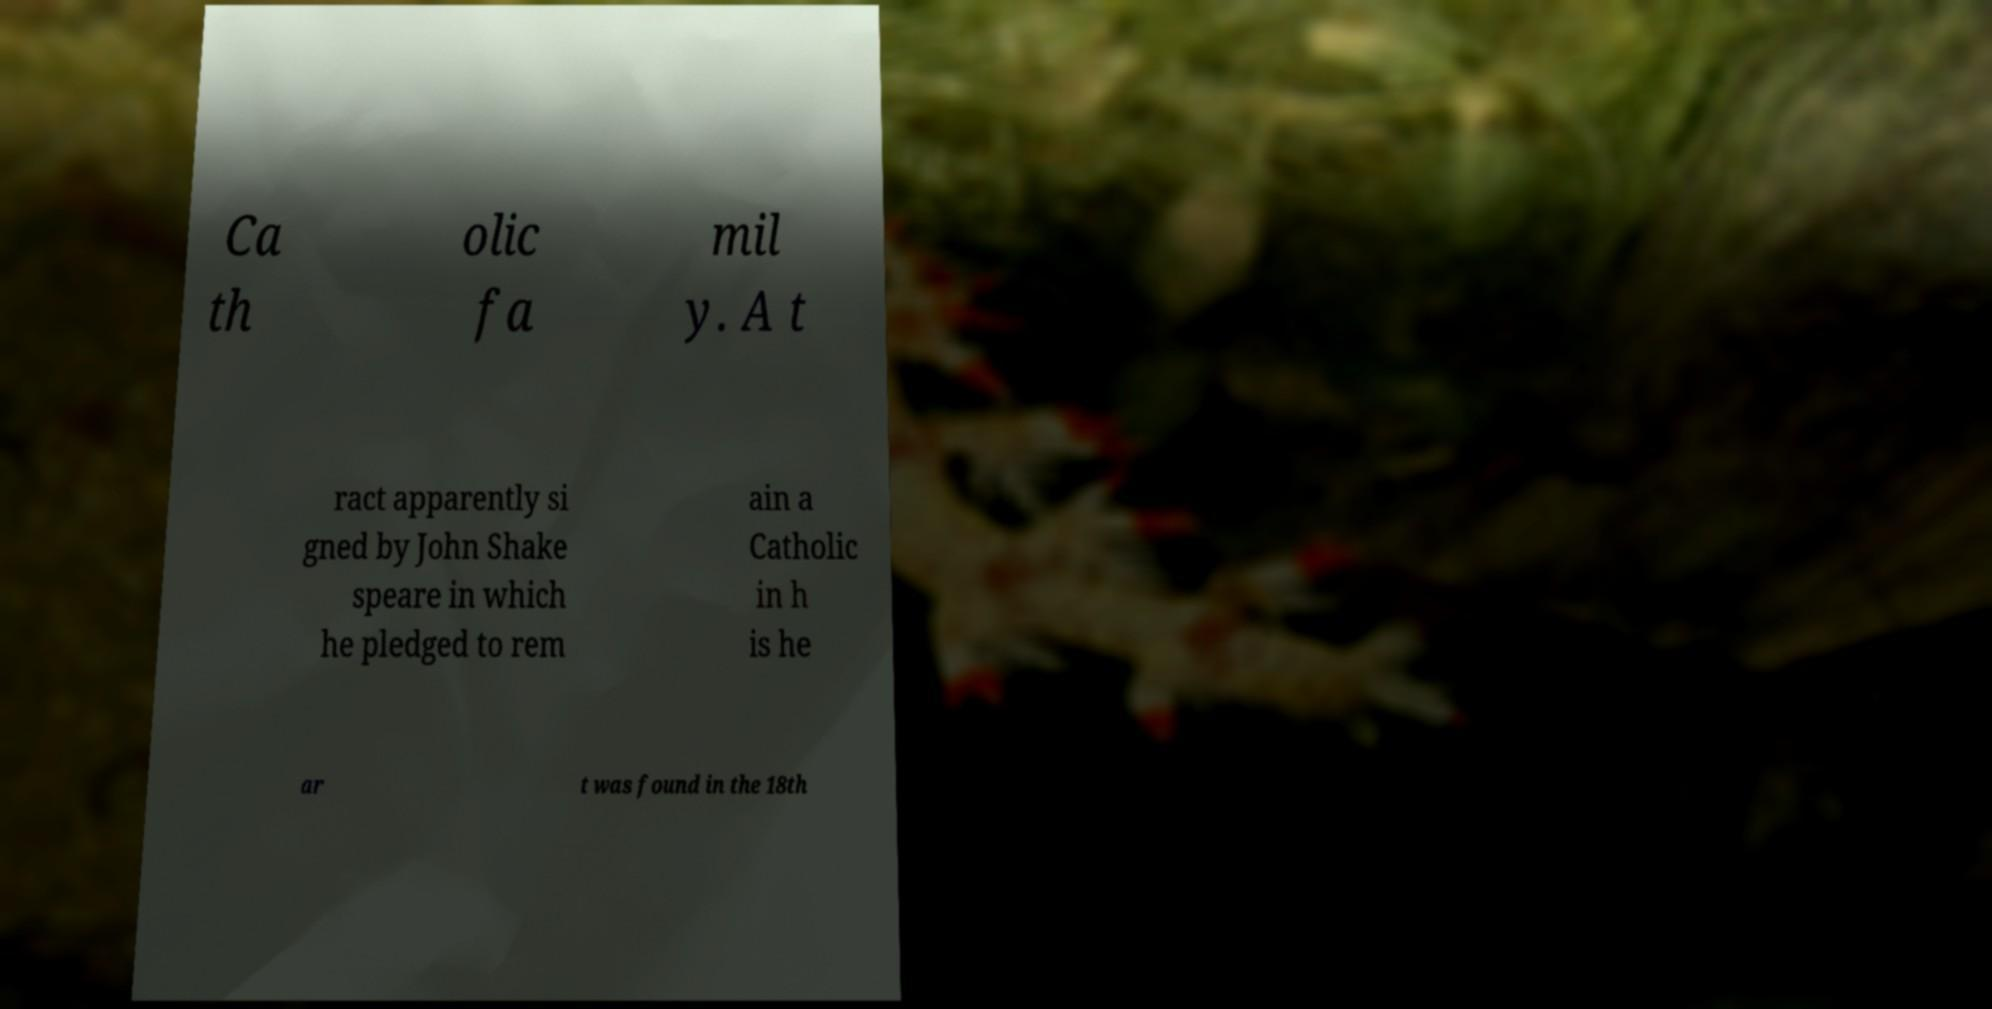Could you extract and type out the text from this image? Ca th olic fa mil y. A t ract apparently si gned by John Shake speare in which he pledged to rem ain a Catholic in h is he ar t was found in the 18th 